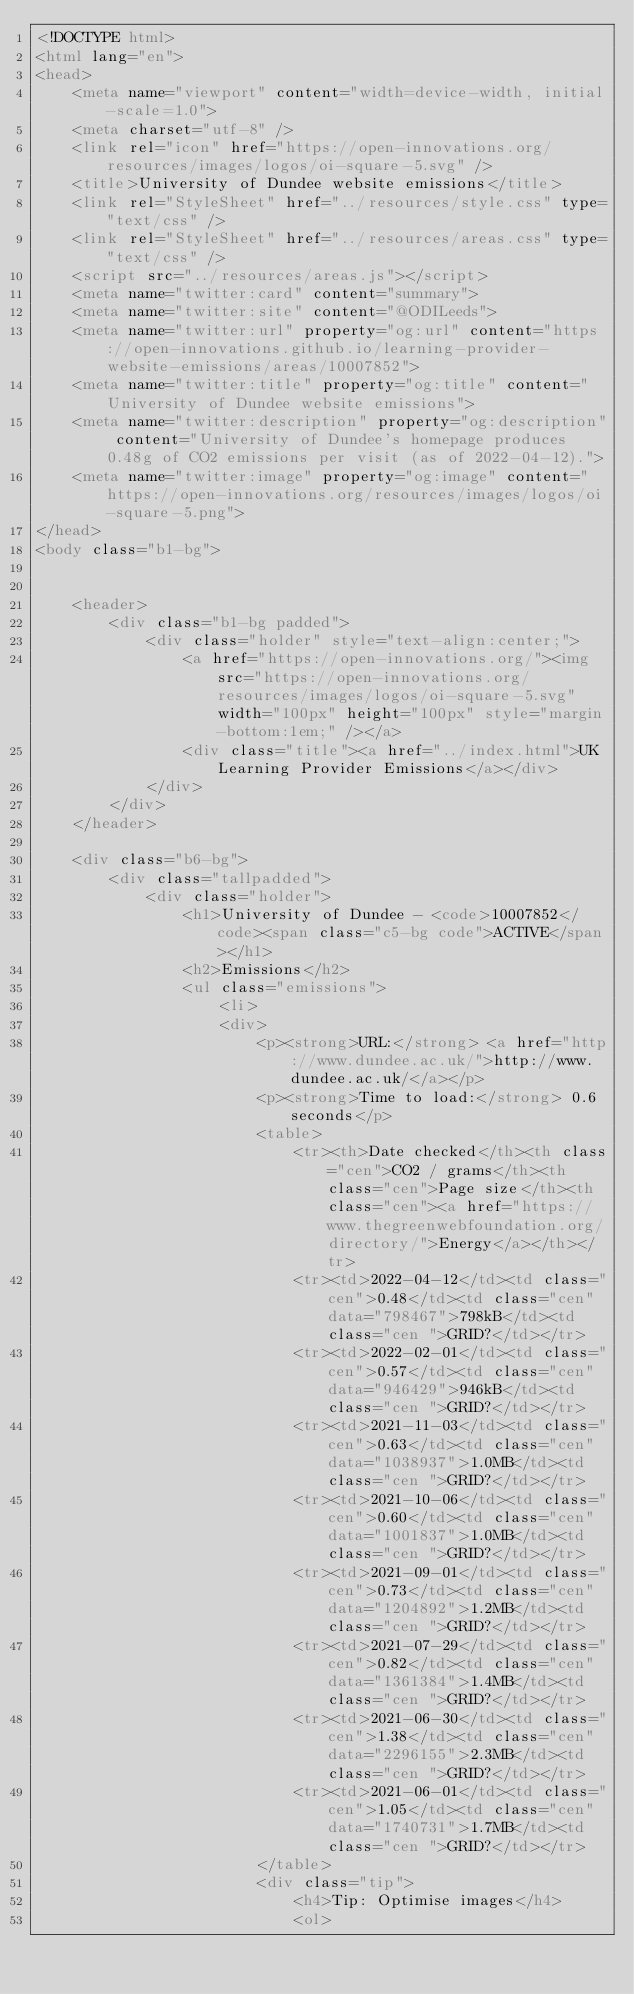<code> <loc_0><loc_0><loc_500><loc_500><_HTML_><!DOCTYPE html>
<html lang="en">
<head>
	<meta name="viewport" content="width=device-width, initial-scale=1.0">
	<meta charset="utf-8" />
	<link rel="icon" href="https://open-innovations.org/resources/images/logos/oi-square-5.svg" />
	<title>University of Dundee website emissions</title>
	<link rel="StyleSheet" href="../resources/style.css" type="text/css" />
	<link rel="StyleSheet" href="../resources/areas.css" type="text/css" />
	<script src="../resources/areas.js"></script>
	<meta name="twitter:card" content="summary">
	<meta name="twitter:site" content="@ODILeeds">
	<meta name="twitter:url" property="og:url" content="https://open-innovations.github.io/learning-provider-website-emissions/areas/10007852">
	<meta name="twitter:title" property="og:title" content="University of Dundee website emissions">
	<meta name="twitter:description" property="og:description" content="University of Dundee's homepage produces 0.48g of CO2 emissions per visit (as of 2022-04-12).">
	<meta name="twitter:image" property="og:image" content="https://open-innovations.org/resources/images/logos/oi-square-5.png">
</head>
<body class="b1-bg">


	<header>
		<div class="b1-bg padded">
			<div class="holder" style="text-align:center;">
				<a href="https://open-innovations.org/"><img src="https://open-innovations.org/resources/images/logos/oi-square-5.svg" width="100px" height="100px" style="margin-bottom:1em;" /></a>
				<div class="title"><a href="../index.html">UK Learning Provider Emissions</a></div>
			</div>
		</div>
	</header>

	<div class="b6-bg">
		<div class="tallpadded">
			<div class="holder">
				<h1>University of Dundee - <code>10007852</code><span class="c5-bg code">ACTIVE</span></h1>
				<h2>Emissions</h2>
				<ul class="emissions">
					<li>
					<div>
						<p><strong>URL:</strong> <a href="http://www.dundee.ac.uk/">http://www.dundee.ac.uk/</a></p>
						<p><strong>Time to load:</strong> 0.6 seconds</p>
						<table>
							<tr><th>Date checked</th><th class="cen">CO2 / grams</th><th class="cen">Page size</th><th class="cen"><a href="https://www.thegreenwebfoundation.org/directory/">Energy</a></th></tr>
							<tr><td>2022-04-12</td><td class="cen">0.48</td><td class="cen" data="798467">798kB</td><td class="cen ">GRID?</td></tr>
							<tr><td>2022-02-01</td><td class="cen">0.57</td><td class="cen" data="946429">946kB</td><td class="cen ">GRID?</td></tr>
							<tr><td>2021-11-03</td><td class="cen">0.63</td><td class="cen" data="1038937">1.0MB</td><td class="cen ">GRID?</td></tr>
							<tr><td>2021-10-06</td><td class="cen">0.60</td><td class="cen" data="1001837">1.0MB</td><td class="cen ">GRID?</td></tr>
							<tr><td>2021-09-01</td><td class="cen">0.73</td><td class="cen" data="1204892">1.2MB</td><td class="cen ">GRID?</td></tr>
							<tr><td>2021-07-29</td><td class="cen">0.82</td><td class="cen" data="1361384">1.4MB</td><td class="cen ">GRID?</td></tr>
							<tr><td>2021-06-30</td><td class="cen">1.38</td><td class="cen" data="2296155">2.3MB</td><td class="cen ">GRID?</td></tr>
							<tr><td>2021-06-01</td><td class="cen">1.05</td><td class="cen" data="1740731">1.7MB</td><td class="cen ">GRID?</td></tr>
						</table>
						<div class="tip">
							<h4>Tip: Optimise images</h4>
							<ol></code> 